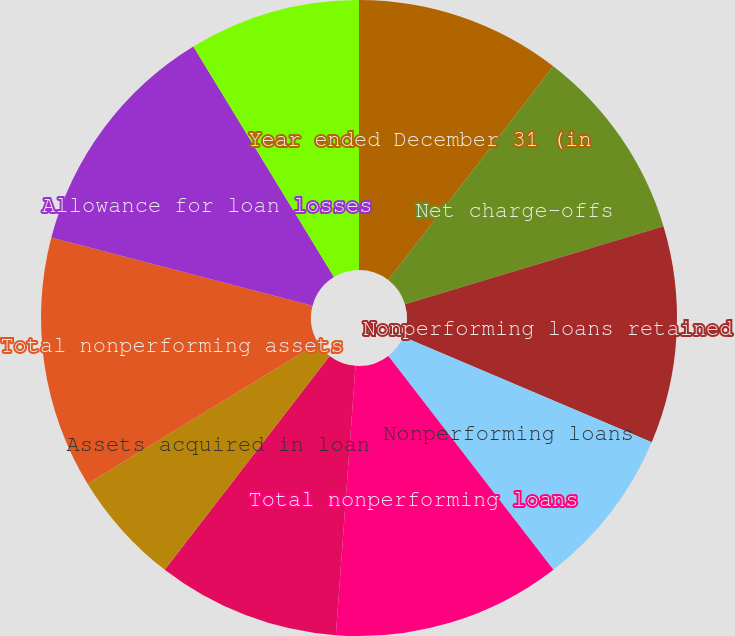Convert chart to OTSL. <chart><loc_0><loc_0><loc_500><loc_500><pie_chart><fcel>Year ended December 31 (in<fcel>Net charge-offs<fcel>Nonperforming loans retained<fcel>Nonperforming loans<fcel>Total nonperforming loans<fcel>Derivative receivables<fcel>Assets acquired in loan<fcel>Total nonperforming assets<fcel>Allowance for loan losses<fcel>Allowance for lending-related<nl><fcel>10.46%<fcel>9.88%<fcel>11.05%<fcel>8.14%<fcel>11.63%<fcel>9.3%<fcel>5.82%<fcel>12.79%<fcel>12.21%<fcel>8.72%<nl></chart> 